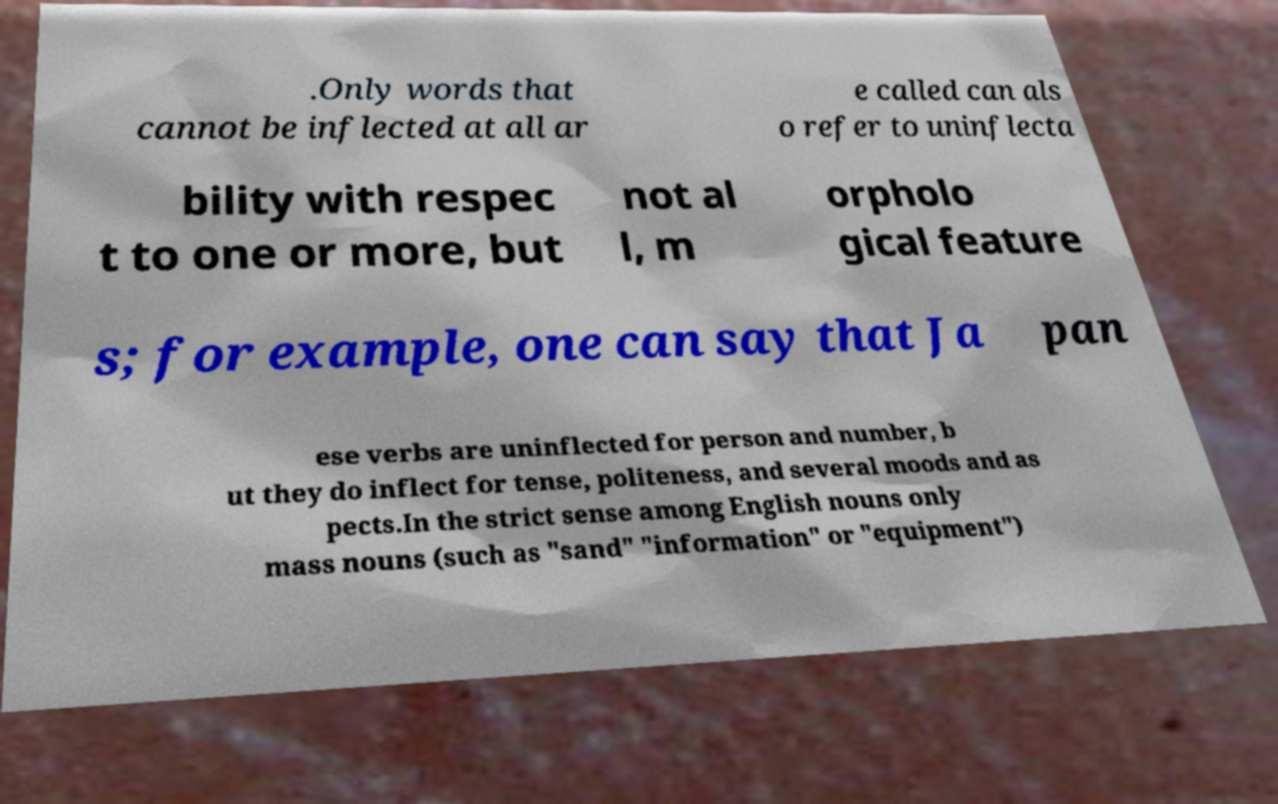I need the written content from this picture converted into text. Can you do that? .Only words that cannot be inflected at all ar e called can als o refer to uninflecta bility with respec t to one or more, but not al l, m orpholo gical feature s; for example, one can say that Ja pan ese verbs are uninflected for person and number, b ut they do inflect for tense, politeness, and several moods and as pects.In the strict sense among English nouns only mass nouns (such as "sand" "information" or "equipment") 